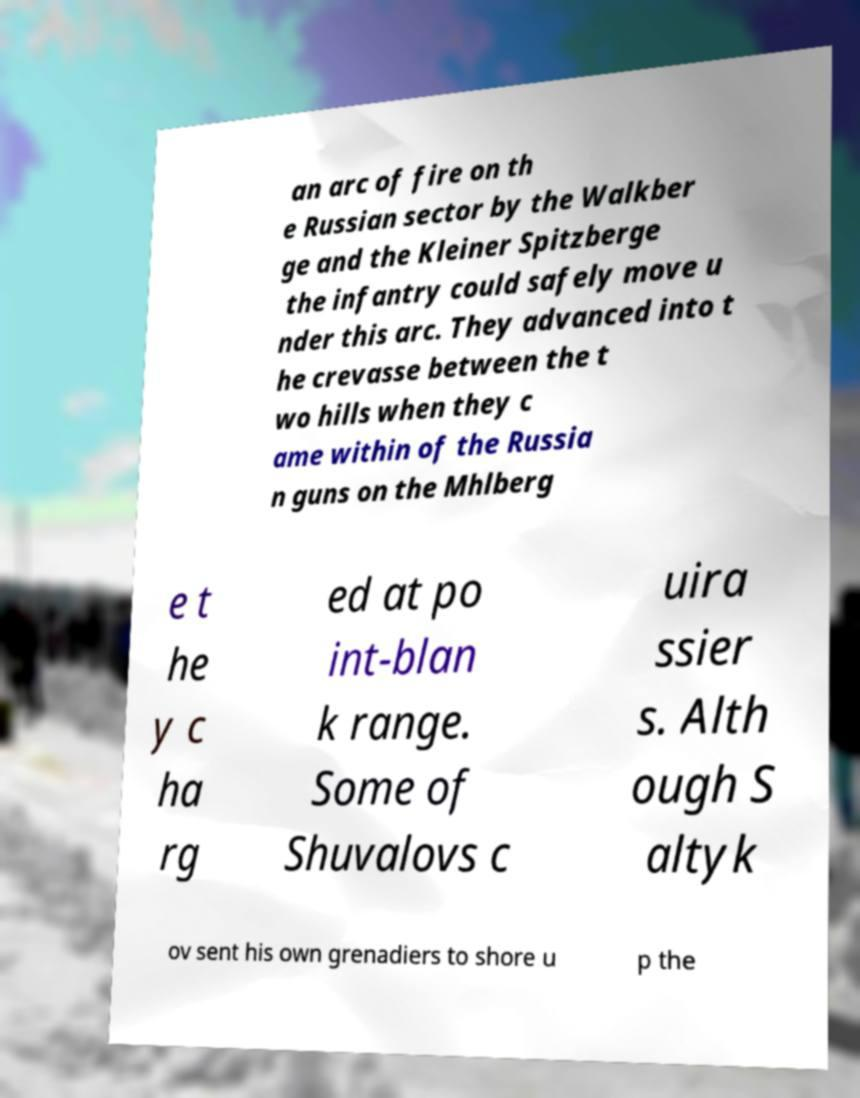Please read and relay the text visible in this image. What does it say? an arc of fire on th e Russian sector by the Walkber ge and the Kleiner Spitzberge the infantry could safely move u nder this arc. They advanced into t he crevasse between the t wo hills when they c ame within of the Russia n guns on the Mhlberg e t he y c ha rg ed at po int-blan k range. Some of Shuvalovs c uira ssier s. Alth ough S altyk ov sent his own grenadiers to shore u p the 